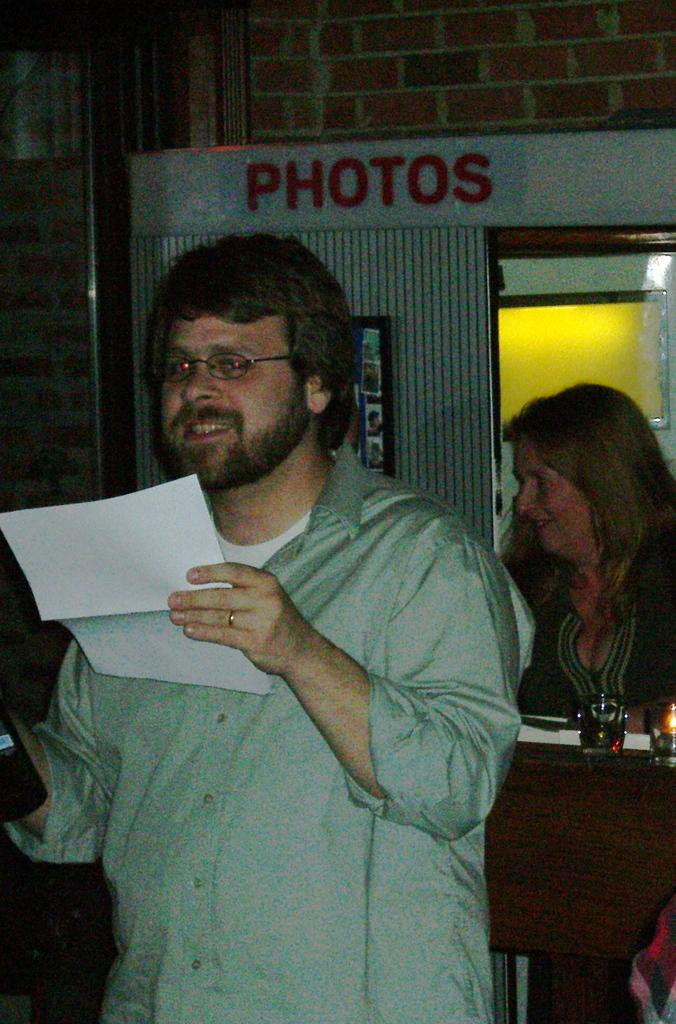What is the person in the image doing? The person is holding a paper and smiling. What can be seen in the background of the image? There is a woman's desk with objects on it, a brick wall, and a glass object in the background. Can you describe the desk in the background? The desk is a woman's desk with objects on it. What is the person holding in the image? The person is holding a paper. Can you tell me how many babies are visible in the image? There are no babies present in the image. What type of pail is used to hold the glass object in the background? There is no pail present in the image, and the glass object is not being held by any container. 